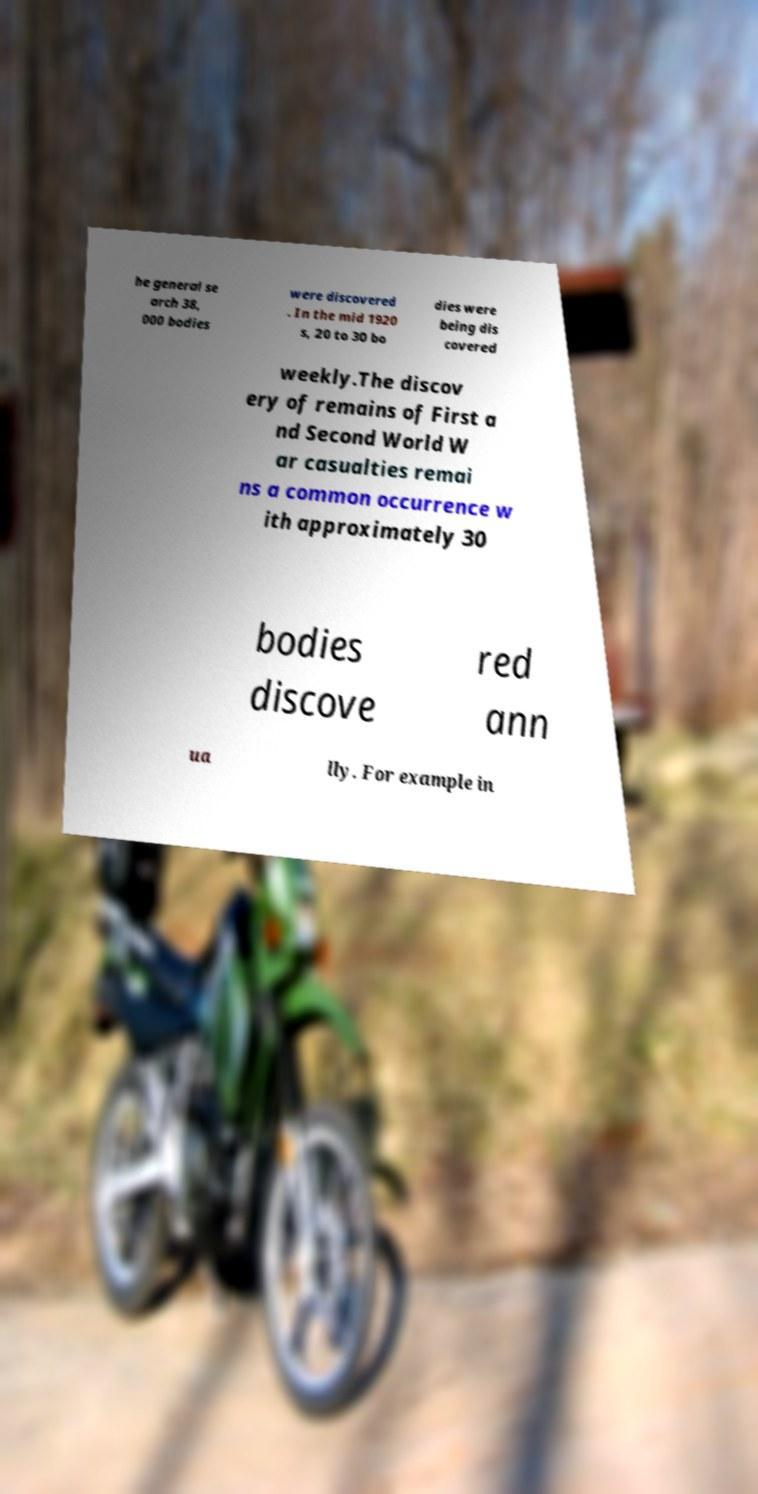I need the written content from this picture converted into text. Can you do that? he general se arch 38, 000 bodies were discovered . In the mid 1920 s, 20 to 30 bo dies were being dis covered weekly.The discov ery of remains of First a nd Second World W ar casualties remai ns a common occurrence w ith approximately 30 bodies discove red ann ua lly. For example in 